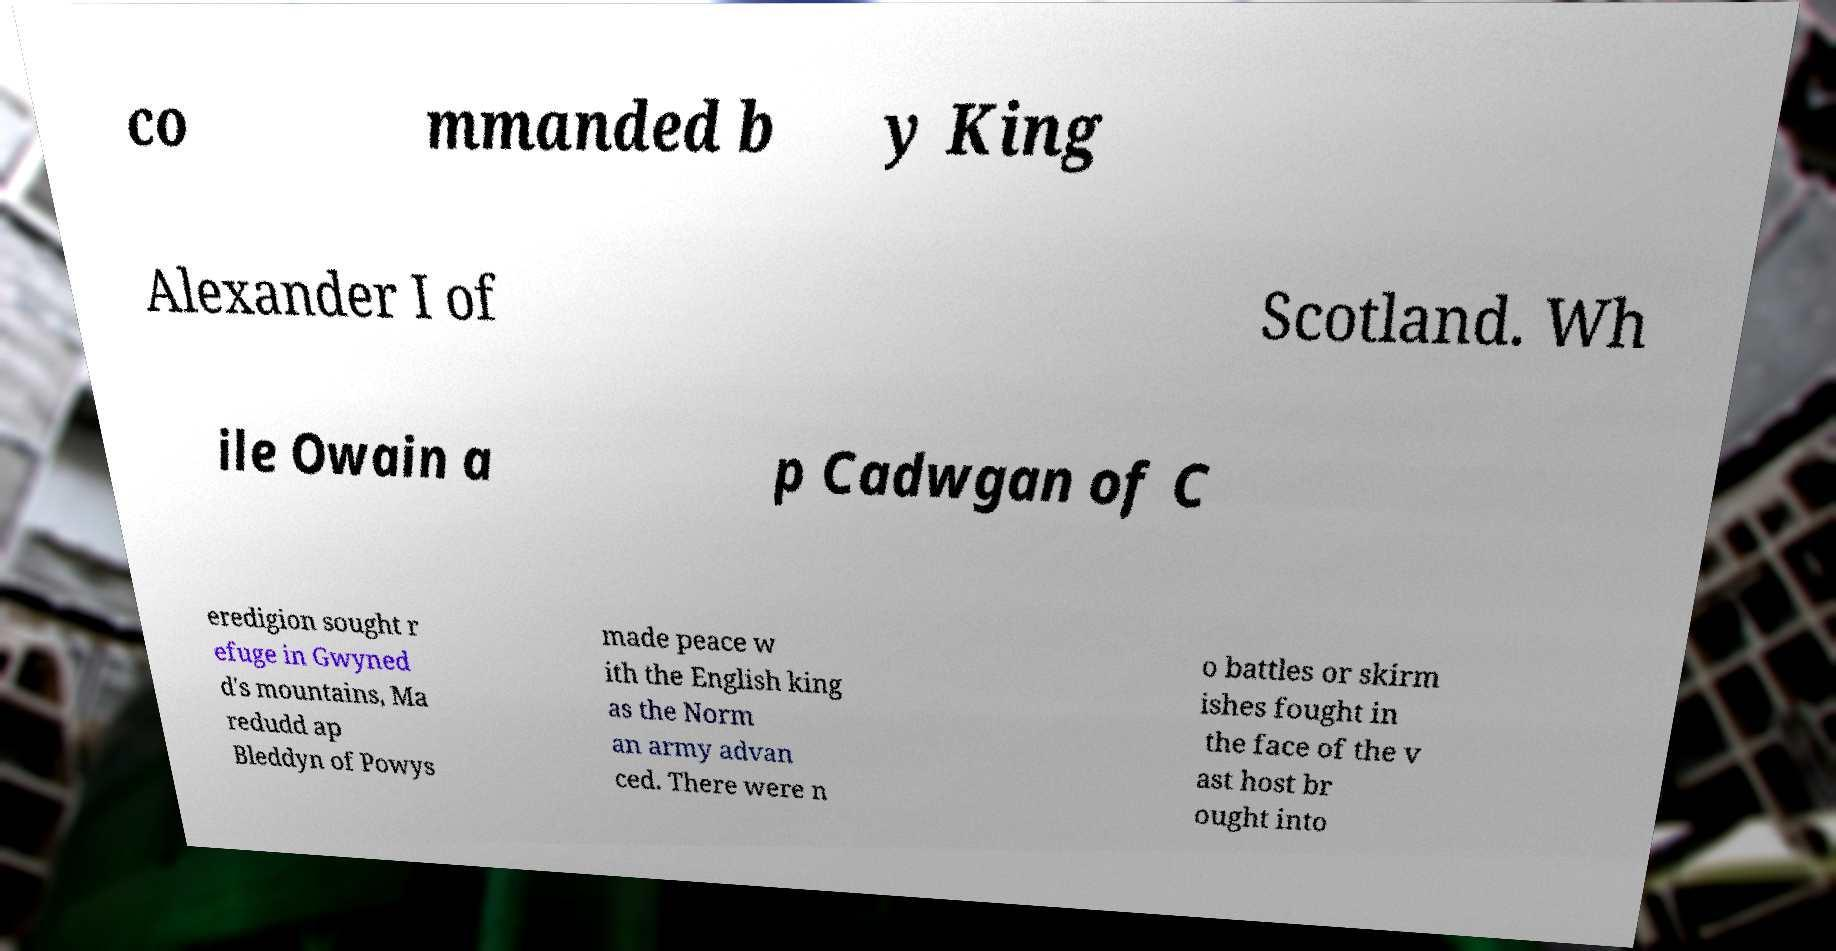Could you assist in decoding the text presented in this image and type it out clearly? co mmanded b y King Alexander I of Scotland. Wh ile Owain a p Cadwgan of C eredigion sought r efuge in Gwyned d's mountains, Ma redudd ap Bleddyn of Powys made peace w ith the English king as the Norm an army advan ced. There were n o battles or skirm ishes fought in the face of the v ast host br ought into 